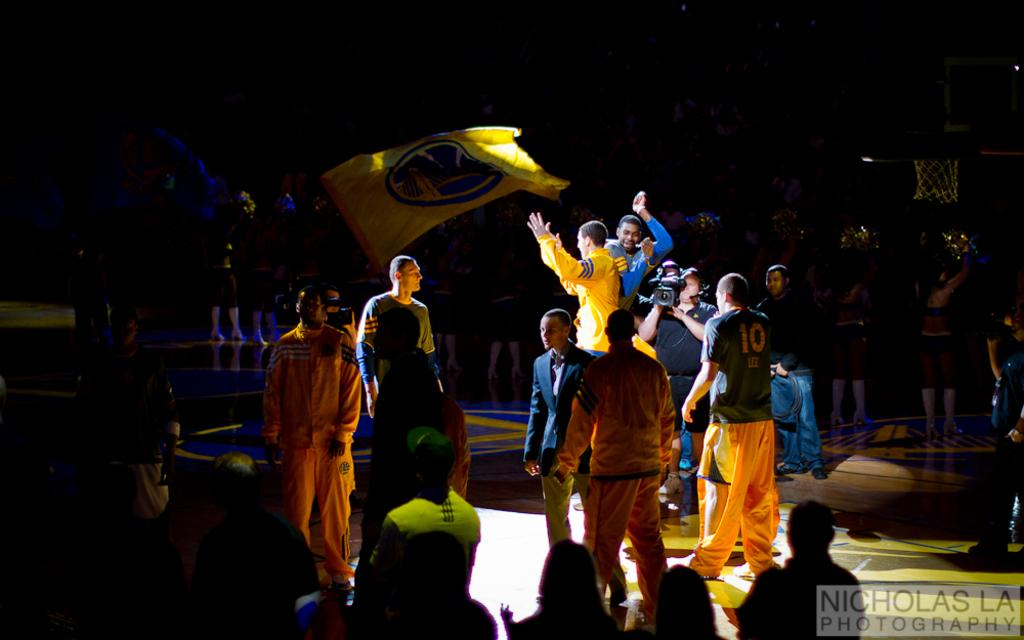How many people are present in the image? There are many people in the image. What type of location is depicted in the image? The setting appears to be an indoor stadium. What can be seen in the middle of the image? There is a yellow flag in the middle of the image. What is the surface beneath the people in the image? There is a floor at the bottom of the image. How would you describe the lighting in the image? The background of the image is dark. What time is the protest scheduled to begin in the image? There is no protest present in the image, and therefore no scheduled time for it to begin. 